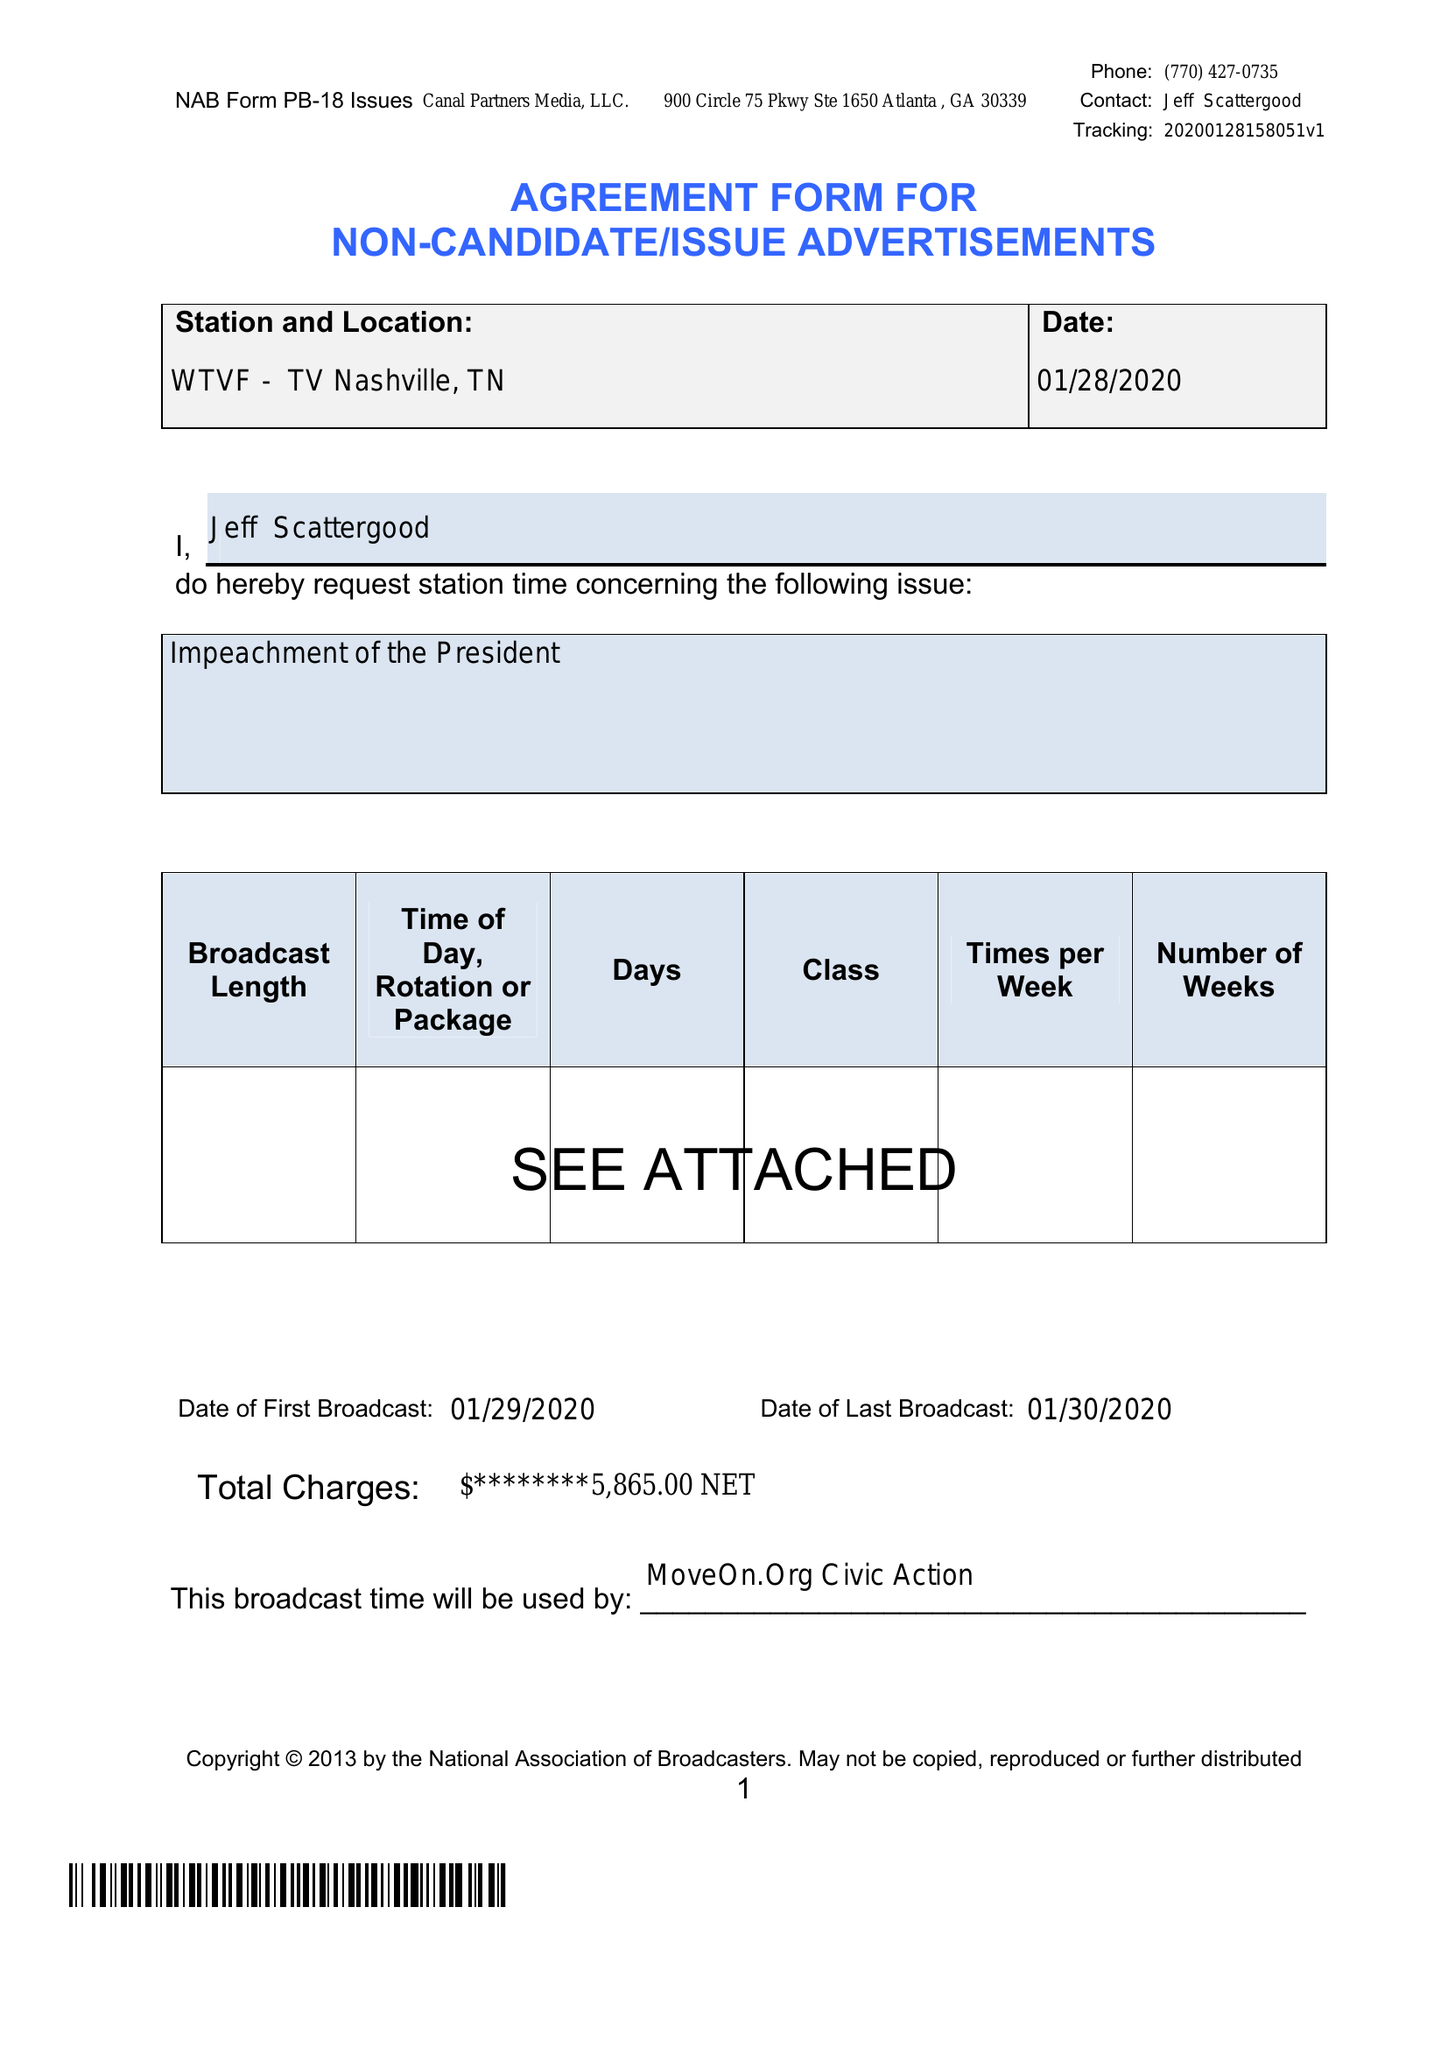What is the value for the contract_num?
Answer the question using a single word or phrase. None 